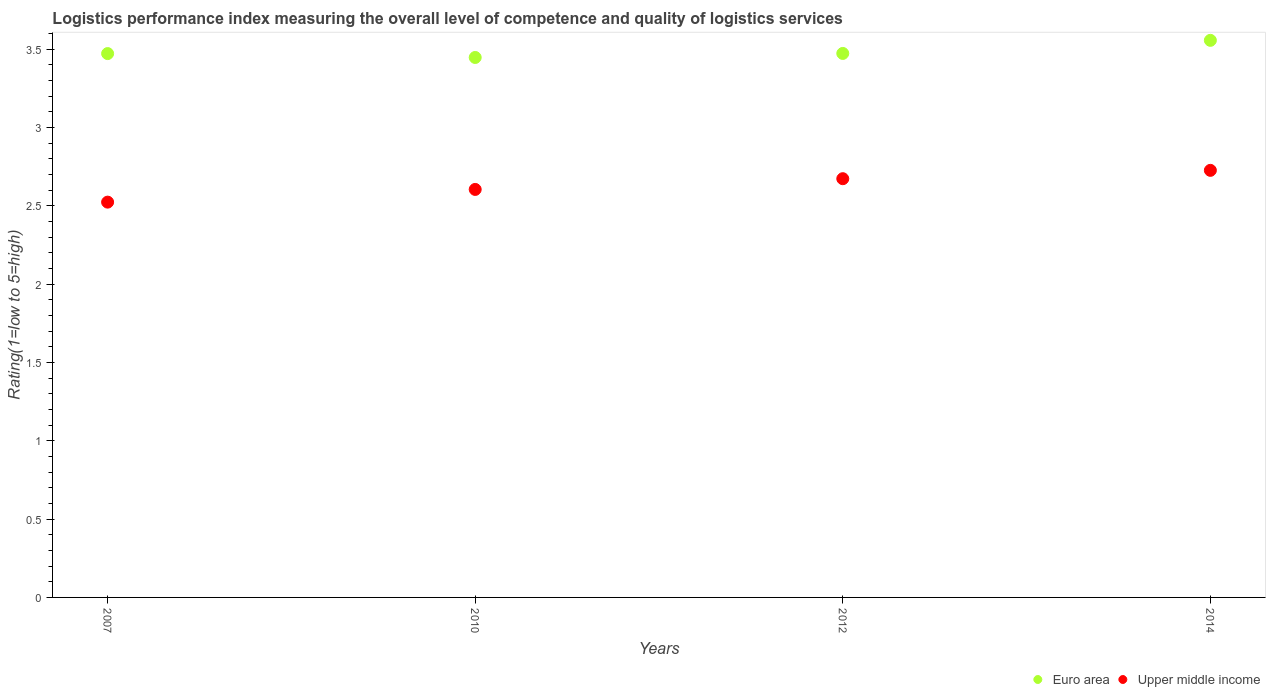How many different coloured dotlines are there?
Offer a very short reply. 2. What is the Logistic performance index in Upper middle income in 2014?
Provide a succinct answer. 2.73. Across all years, what is the maximum Logistic performance index in Euro area?
Ensure brevity in your answer.  3.56. Across all years, what is the minimum Logistic performance index in Upper middle income?
Offer a terse response. 2.52. In which year was the Logistic performance index in Euro area maximum?
Offer a very short reply. 2014. What is the total Logistic performance index in Upper middle income in the graph?
Keep it short and to the point. 10.53. What is the difference between the Logistic performance index in Euro area in 2007 and that in 2014?
Your answer should be compact. -0.08. What is the difference between the Logistic performance index in Upper middle income in 2007 and the Logistic performance index in Euro area in 2010?
Provide a succinct answer. -0.92. What is the average Logistic performance index in Upper middle income per year?
Ensure brevity in your answer.  2.63. In the year 2007, what is the difference between the Logistic performance index in Euro area and Logistic performance index in Upper middle income?
Offer a terse response. 0.95. In how many years, is the Logistic performance index in Upper middle income greater than 0.6?
Keep it short and to the point. 4. What is the ratio of the Logistic performance index in Upper middle income in 2010 to that in 2012?
Your response must be concise. 0.97. What is the difference between the highest and the second highest Logistic performance index in Euro area?
Provide a succinct answer. 0.08. What is the difference between the highest and the lowest Logistic performance index in Upper middle income?
Offer a terse response. 0.2. Is the sum of the Logistic performance index in Upper middle income in 2007 and 2010 greater than the maximum Logistic performance index in Euro area across all years?
Provide a succinct answer. Yes. Does the Logistic performance index in Upper middle income monotonically increase over the years?
Offer a terse response. Yes. Is the Logistic performance index in Upper middle income strictly greater than the Logistic performance index in Euro area over the years?
Your answer should be compact. No. Is the Logistic performance index in Upper middle income strictly less than the Logistic performance index in Euro area over the years?
Offer a terse response. Yes. How many years are there in the graph?
Make the answer very short. 4. Are the values on the major ticks of Y-axis written in scientific E-notation?
Your answer should be very brief. No. Does the graph contain grids?
Give a very brief answer. No. How are the legend labels stacked?
Offer a very short reply. Horizontal. What is the title of the graph?
Provide a succinct answer. Logistics performance index measuring the overall level of competence and quality of logistics services. Does "Honduras" appear as one of the legend labels in the graph?
Give a very brief answer. No. What is the label or title of the Y-axis?
Provide a succinct answer. Rating(1=low to 5=high). What is the Rating(1=low to 5=high) of Euro area in 2007?
Make the answer very short. 3.47. What is the Rating(1=low to 5=high) in Upper middle income in 2007?
Offer a very short reply. 2.52. What is the Rating(1=low to 5=high) of Euro area in 2010?
Your response must be concise. 3.45. What is the Rating(1=low to 5=high) in Upper middle income in 2010?
Your response must be concise. 2.6. What is the Rating(1=low to 5=high) in Euro area in 2012?
Give a very brief answer. 3.47. What is the Rating(1=low to 5=high) of Upper middle income in 2012?
Make the answer very short. 2.67. What is the Rating(1=low to 5=high) in Euro area in 2014?
Offer a terse response. 3.56. What is the Rating(1=low to 5=high) of Upper middle income in 2014?
Your answer should be compact. 2.73. Across all years, what is the maximum Rating(1=low to 5=high) of Euro area?
Your answer should be compact. 3.56. Across all years, what is the maximum Rating(1=low to 5=high) in Upper middle income?
Your answer should be very brief. 2.73. Across all years, what is the minimum Rating(1=low to 5=high) of Euro area?
Provide a succinct answer. 3.45. Across all years, what is the minimum Rating(1=low to 5=high) in Upper middle income?
Provide a short and direct response. 2.52. What is the total Rating(1=low to 5=high) of Euro area in the graph?
Keep it short and to the point. 13.95. What is the total Rating(1=low to 5=high) of Upper middle income in the graph?
Your answer should be compact. 10.53. What is the difference between the Rating(1=low to 5=high) in Euro area in 2007 and that in 2010?
Offer a terse response. 0.02. What is the difference between the Rating(1=low to 5=high) in Upper middle income in 2007 and that in 2010?
Your answer should be compact. -0.08. What is the difference between the Rating(1=low to 5=high) in Euro area in 2007 and that in 2012?
Your answer should be very brief. -0. What is the difference between the Rating(1=low to 5=high) in Upper middle income in 2007 and that in 2012?
Your response must be concise. -0.15. What is the difference between the Rating(1=low to 5=high) of Euro area in 2007 and that in 2014?
Your answer should be very brief. -0.08. What is the difference between the Rating(1=low to 5=high) in Upper middle income in 2007 and that in 2014?
Keep it short and to the point. -0.2. What is the difference between the Rating(1=low to 5=high) of Euro area in 2010 and that in 2012?
Give a very brief answer. -0.03. What is the difference between the Rating(1=low to 5=high) of Upper middle income in 2010 and that in 2012?
Your answer should be very brief. -0.07. What is the difference between the Rating(1=low to 5=high) in Euro area in 2010 and that in 2014?
Offer a very short reply. -0.11. What is the difference between the Rating(1=low to 5=high) in Upper middle income in 2010 and that in 2014?
Ensure brevity in your answer.  -0.12. What is the difference between the Rating(1=low to 5=high) in Euro area in 2012 and that in 2014?
Provide a short and direct response. -0.08. What is the difference between the Rating(1=low to 5=high) of Upper middle income in 2012 and that in 2014?
Offer a terse response. -0.05. What is the difference between the Rating(1=low to 5=high) in Euro area in 2007 and the Rating(1=low to 5=high) in Upper middle income in 2010?
Your response must be concise. 0.87. What is the difference between the Rating(1=low to 5=high) of Euro area in 2007 and the Rating(1=low to 5=high) of Upper middle income in 2012?
Make the answer very short. 0.8. What is the difference between the Rating(1=low to 5=high) in Euro area in 2007 and the Rating(1=low to 5=high) in Upper middle income in 2014?
Your answer should be very brief. 0.75. What is the difference between the Rating(1=low to 5=high) of Euro area in 2010 and the Rating(1=low to 5=high) of Upper middle income in 2012?
Keep it short and to the point. 0.77. What is the difference between the Rating(1=low to 5=high) of Euro area in 2010 and the Rating(1=low to 5=high) of Upper middle income in 2014?
Your response must be concise. 0.72. What is the difference between the Rating(1=low to 5=high) in Euro area in 2012 and the Rating(1=low to 5=high) in Upper middle income in 2014?
Your answer should be very brief. 0.75. What is the average Rating(1=low to 5=high) in Euro area per year?
Give a very brief answer. 3.49. What is the average Rating(1=low to 5=high) of Upper middle income per year?
Your answer should be compact. 2.63. In the year 2007, what is the difference between the Rating(1=low to 5=high) of Euro area and Rating(1=low to 5=high) of Upper middle income?
Ensure brevity in your answer.  0.95. In the year 2010, what is the difference between the Rating(1=low to 5=high) of Euro area and Rating(1=low to 5=high) of Upper middle income?
Provide a succinct answer. 0.84. In the year 2012, what is the difference between the Rating(1=low to 5=high) in Euro area and Rating(1=low to 5=high) in Upper middle income?
Make the answer very short. 0.8. In the year 2014, what is the difference between the Rating(1=low to 5=high) of Euro area and Rating(1=low to 5=high) of Upper middle income?
Your answer should be compact. 0.83. What is the ratio of the Rating(1=low to 5=high) in Upper middle income in 2007 to that in 2010?
Provide a succinct answer. 0.97. What is the ratio of the Rating(1=low to 5=high) of Upper middle income in 2007 to that in 2012?
Give a very brief answer. 0.94. What is the ratio of the Rating(1=low to 5=high) in Euro area in 2007 to that in 2014?
Make the answer very short. 0.98. What is the ratio of the Rating(1=low to 5=high) of Upper middle income in 2007 to that in 2014?
Your answer should be compact. 0.93. What is the ratio of the Rating(1=low to 5=high) of Euro area in 2010 to that in 2012?
Offer a very short reply. 0.99. What is the ratio of the Rating(1=low to 5=high) of Upper middle income in 2010 to that in 2012?
Make the answer very short. 0.97. What is the ratio of the Rating(1=low to 5=high) of Euro area in 2010 to that in 2014?
Keep it short and to the point. 0.97. What is the ratio of the Rating(1=low to 5=high) in Upper middle income in 2010 to that in 2014?
Provide a short and direct response. 0.96. What is the ratio of the Rating(1=low to 5=high) of Euro area in 2012 to that in 2014?
Your response must be concise. 0.98. What is the ratio of the Rating(1=low to 5=high) in Upper middle income in 2012 to that in 2014?
Offer a very short reply. 0.98. What is the difference between the highest and the second highest Rating(1=low to 5=high) of Euro area?
Keep it short and to the point. 0.08. What is the difference between the highest and the second highest Rating(1=low to 5=high) in Upper middle income?
Keep it short and to the point. 0.05. What is the difference between the highest and the lowest Rating(1=low to 5=high) in Euro area?
Offer a terse response. 0.11. What is the difference between the highest and the lowest Rating(1=low to 5=high) of Upper middle income?
Your answer should be compact. 0.2. 